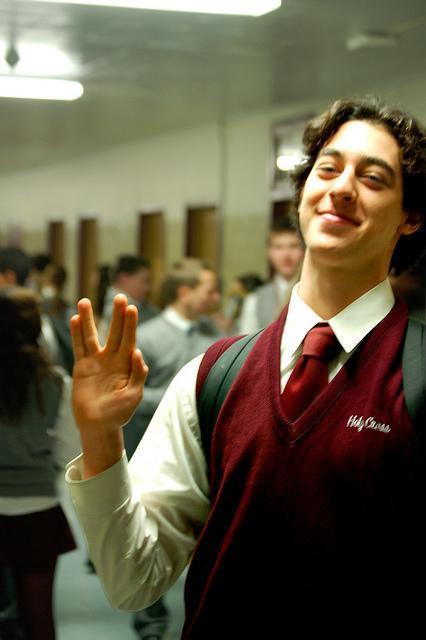What school does this boy attend?
Pick the right solution, then justify: 'Answer: answer
Rationale: rationale.'
Options: None, elementary, harvard, holy cross. Answer: holy cross.
Rationale: The boy is wearing a school uniform and the name of the school is embroidered on his sweater. 